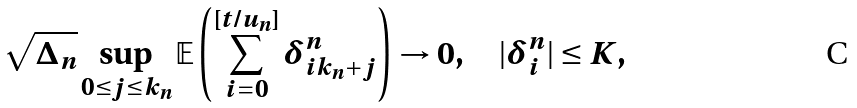Convert formula to latex. <formula><loc_0><loc_0><loc_500><loc_500>\sqrt { \Delta _ { n } } \sup _ { 0 \leq j \leq k _ { n } } \mathbb { E } \left ( \sum _ { i = 0 } ^ { [ t / u _ { n } ] } \delta ^ { n } _ { i k _ { n } + j } \right ) \to 0 , \quad | \delta ^ { n } _ { i } | \leq K ,</formula> 